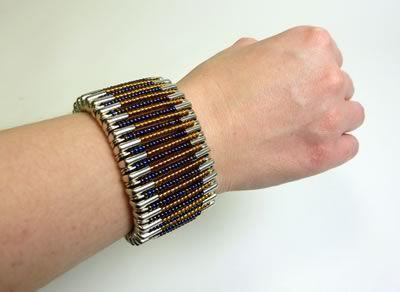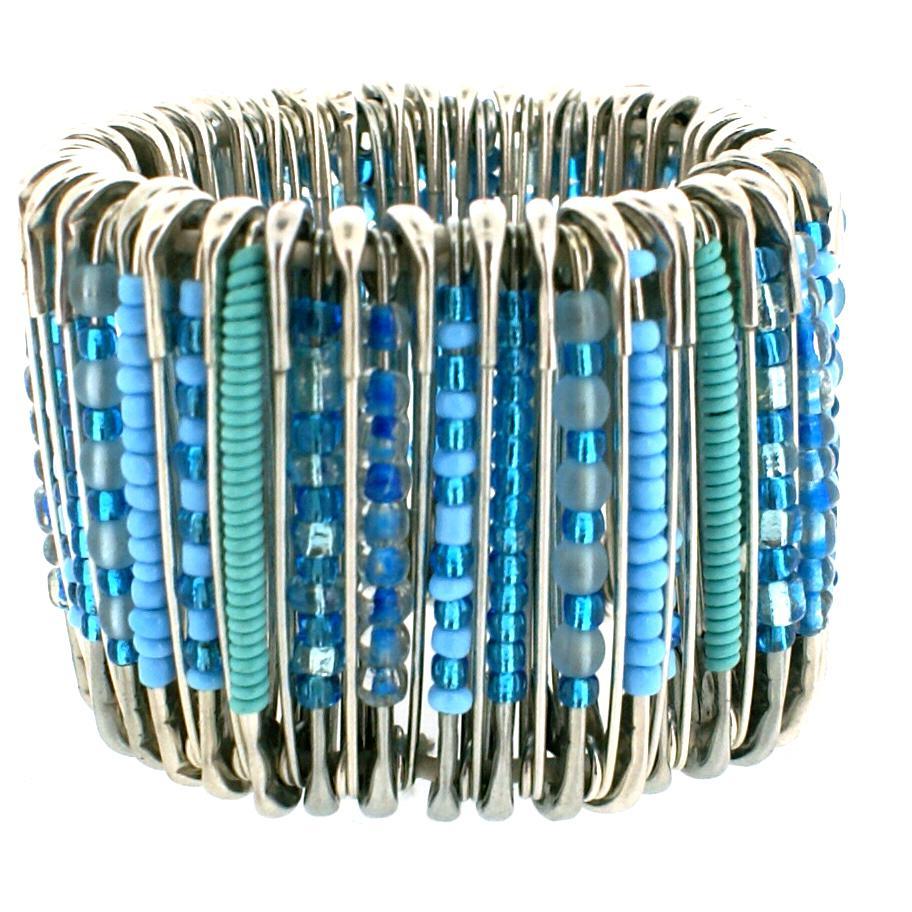The first image is the image on the left, the second image is the image on the right. Examine the images to the left and right. Is the description "One of the bracelets features small, round, rainbow colored beads including the colors pink and orange." accurate? Answer yes or no. No. The first image is the image on the left, the second image is the image on the right. Examine the images to the left and right. Is the description "jewelry made from bobby pins are on human wrists" accurate? Answer yes or no. Yes. 